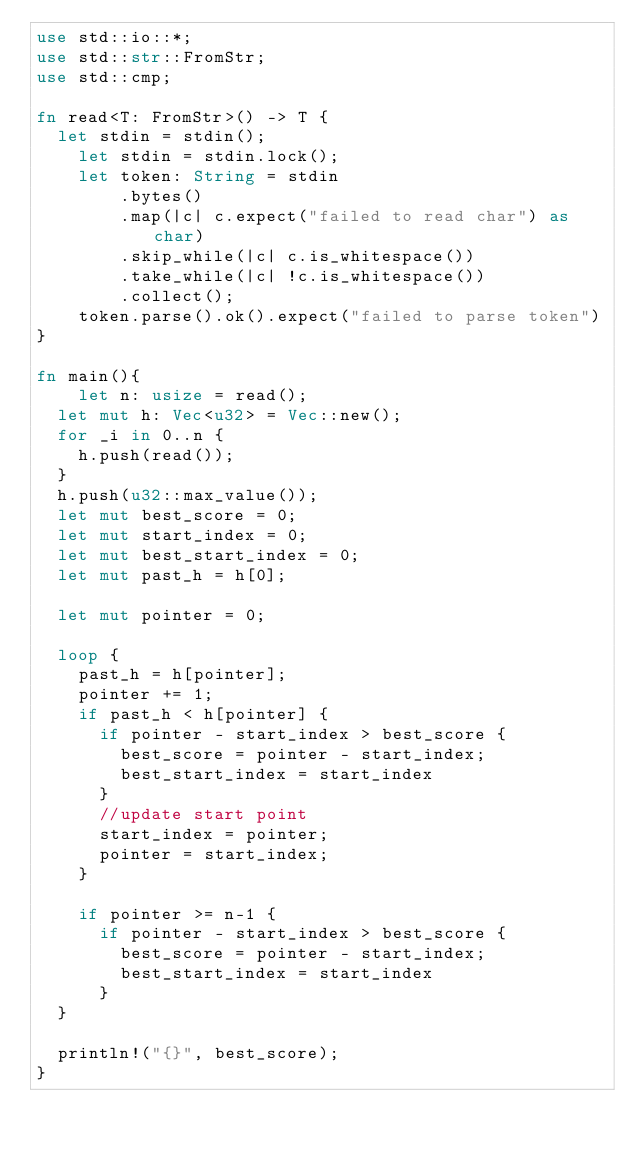<code> <loc_0><loc_0><loc_500><loc_500><_Rust_>use std::io::*;
use std::str::FromStr;
use std::cmp;
   
fn read<T: FromStr>() -> T {
	let stdin = stdin();
    let stdin = stdin.lock();
    let token: String = stdin
        .bytes()
        .map(|c| c.expect("failed to read char") as char)
        .skip_while(|c| c.is_whitespace())
        .take_while(|c| !c.is_whitespace())
        .collect();
    token.parse().ok().expect("failed to parse token")
}

fn main(){
    let n: usize = read();
	let mut h: Vec<u32> = Vec::new();
	for _i in 0..n {
		h.push(read());
	}
	h.push(u32::max_value());
	let mut best_score = 0;
	let mut start_index = 0;
	let mut best_start_index = 0;
	let mut past_h = h[0];

	let mut pointer = 0;

	loop {
		past_h = h[pointer];
		pointer += 1;
		if past_h < h[pointer] {
			if pointer - start_index > best_score {
				best_score = pointer - start_index;
				best_start_index = start_index
			}
			//update start point
			start_index = pointer;
			pointer = start_index;
		}

		if pointer >= n-1 {
			if pointer - start_index > best_score {
				best_score = pointer - start_index;
				best_start_index = start_index
			}			
	}

	println!("{}", best_score);
}
</code> 